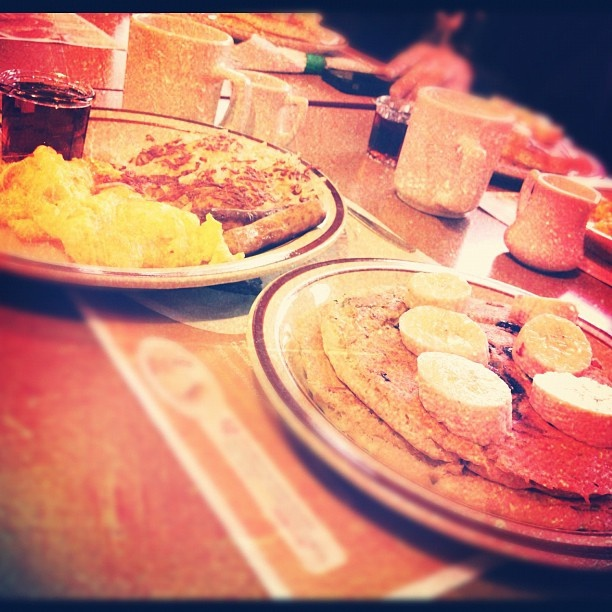Describe the objects in this image and their specific colors. I can see dining table in navy, salmon, and tan tones, people in navy and salmon tones, cup in navy, tan, and salmon tones, banana in navy, khaki, beige, and salmon tones, and pizza in navy, khaki, and salmon tones in this image. 